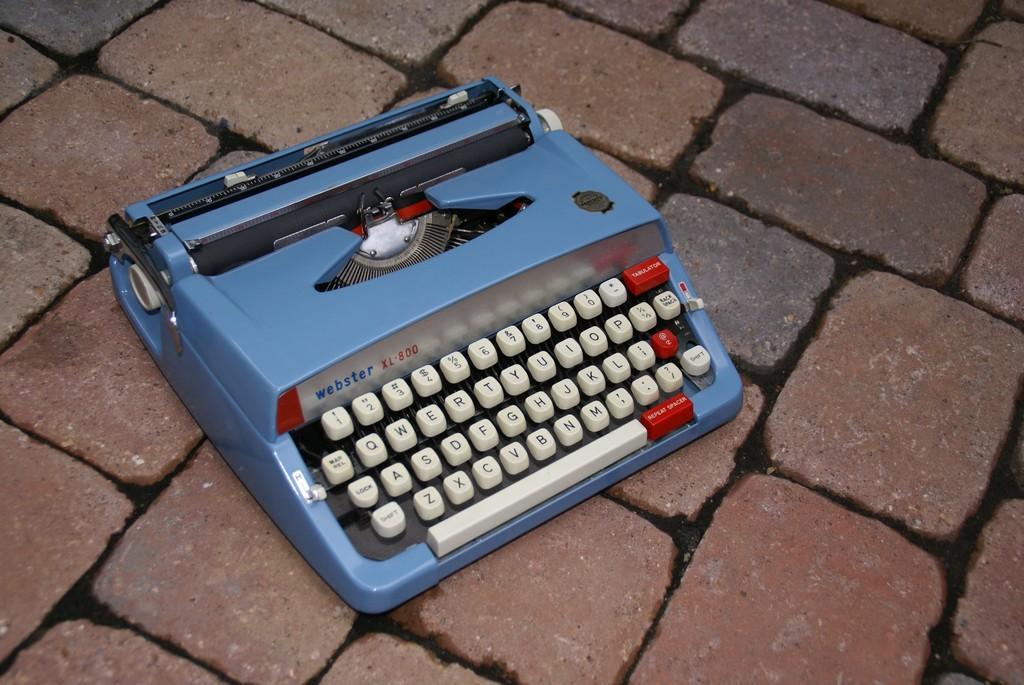What brand or model typewriter is this?
Offer a terse response. Webster. What is the letter to the right of q?
Provide a succinct answer. W. 